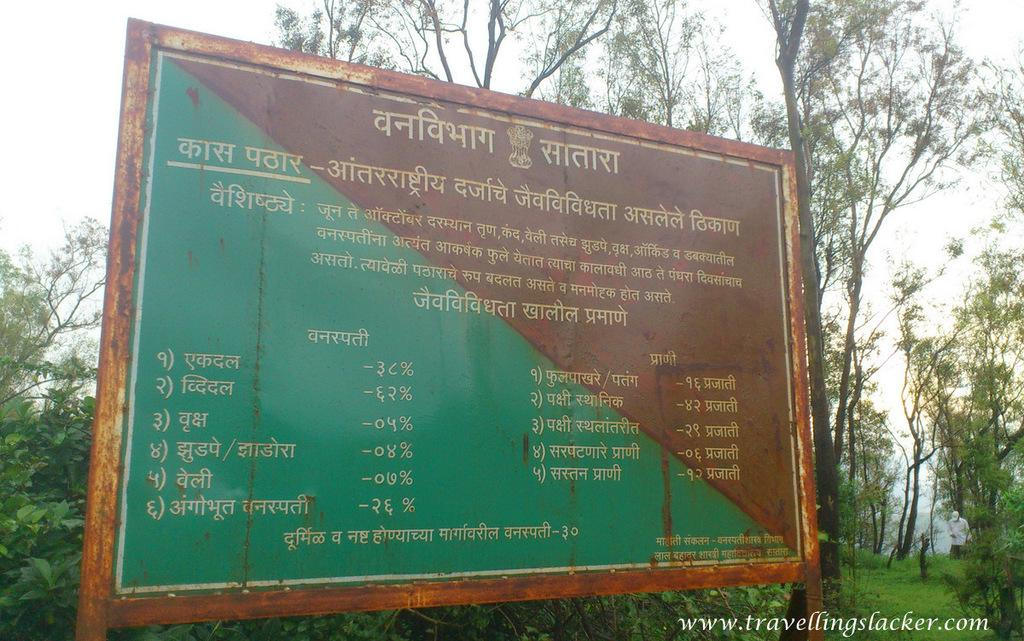What is the main object in the image with information? There is a board with information in the image. What can be seen in the background of the image? There are trees, grass, a person, and sky visible in the background of the image. Where is the text located in the image? The text is in the bottom right side of the image. What type of pin is being used to hold the board in place in the image? There is no pin visible in the image; the board is not being held in place by any pin. 